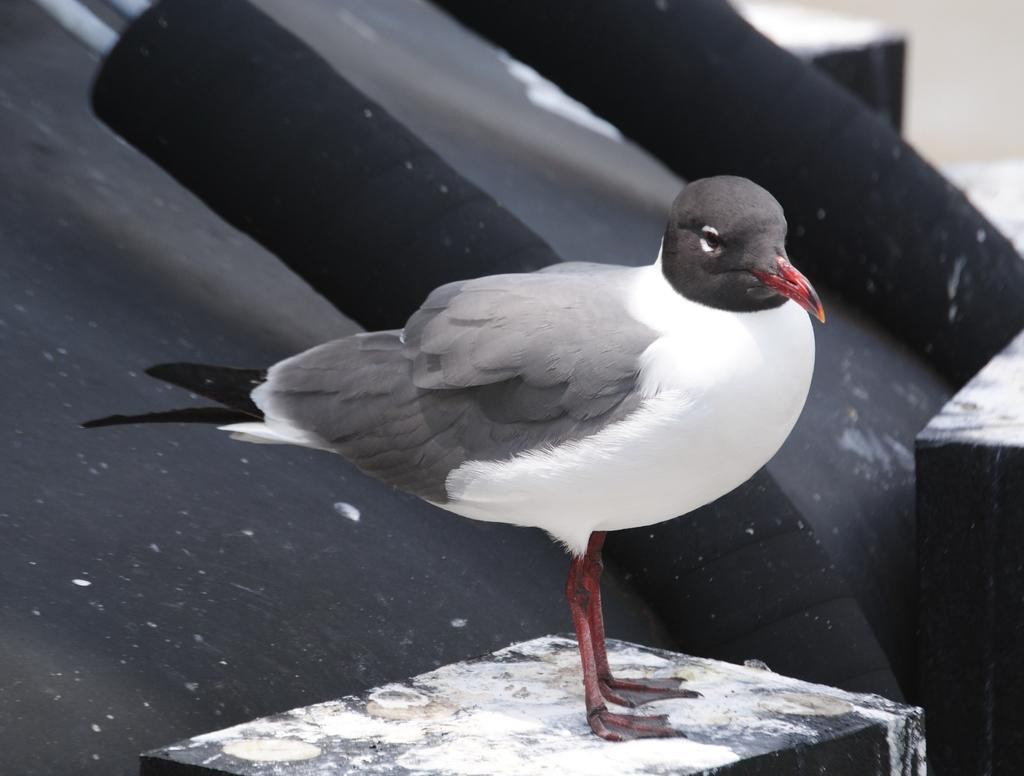What type of animal is in the image? There is a bird in the image. What colors can be seen on the bird? The bird has white, gray, and black colors. What is the color of the bird's beak? The bird has a red beak. What is the color of the bird's legs? The bird has red legs. What is the bird standing on in the image? The bird is standing on a stand. What color is the background of the image? The background of the image is black. What is the title of the book the bird is reading in the image? There is no book present in the image, so there is no title to mention. 